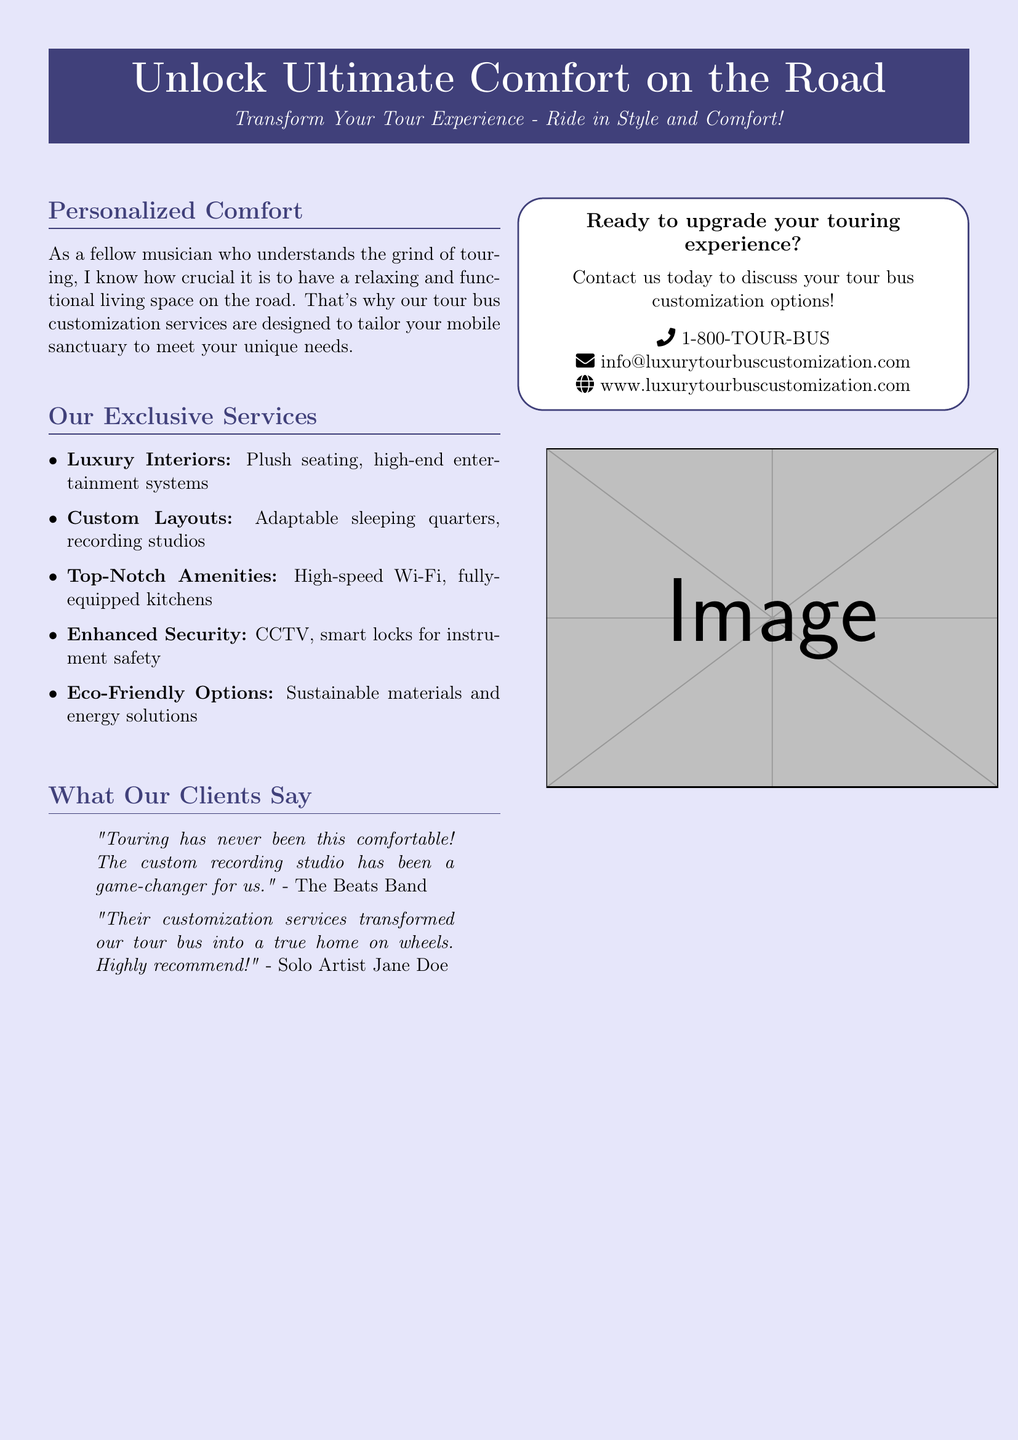What is the primary offering of the document? The document is an advertisement for tour bus customization services, aimed at enhancing comfort for musicians on the road.
Answer: Tour bus customization services What are two luxury features mentioned for the tour buses? The document lists luxury interiors and high-end entertainment systems as specific luxury amenities provided for the tour buses.
Answer: Plush seating, high-end entertainment systems What type of security features are highlighted in the document? The advertisement mentions CCTV and smart locks as part of the enhanced security options for the tour buses.
Answer: CCTV, smart locks Which artist provided a testimonial claiming the customization transformed their tour bus? The document features a testimonial from Solo Artist Jane Doe regarding the impact of the company's customization services.
Answer: Solo Artist Jane Doe How can potential customers contact the service provider? Potential customers are encouraged to reach out through a phone number or email, which are both provided in the document.
Answer: 1-800-TOUR-BUS, info@luxurytourbuscustomization.com What is one eco-friendly option provided for the tour buses? The document indicates that sustainable materials and energy solutions are offered as eco-friendly customization options.
Answer: Sustainable materials and energy solutions What does the document suggest for enhanced comfort while touring? The services are designed to modify tour buses to make them more comfortable for artists, specifically tailored to their needs while on the road.
Answer: Personalized comfort What type of clients does this advertisement target? This advertisement primarily targets musicians and performers who frequently tour and need a comfortable living space on the road.
Answer: Musicians, performers What is included in the service for recording? The document mentions that customizable layouts can include recording studios for artists to utilize while touring.
Answer: Recording studios 